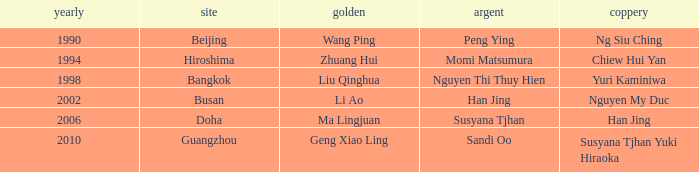What Gold has the Year of 1994? Zhuang Hui. 